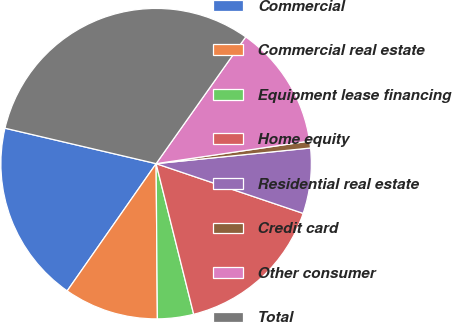Convert chart. <chart><loc_0><loc_0><loc_500><loc_500><pie_chart><fcel>Commercial<fcel>Commercial real estate<fcel>Equipment lease financing<fcel>Home equity<fcel>Residential real estate<fcel>Credit card<fcel>Other consumer<fcel>Total<nl><fcel>18.96%<fcel>9.84%<fcel>3.76%<fcel>15.92%<fcel>6.8%<fcel>0.72%<fcel>12.88%<fcel>31.13%<nl></chart> 